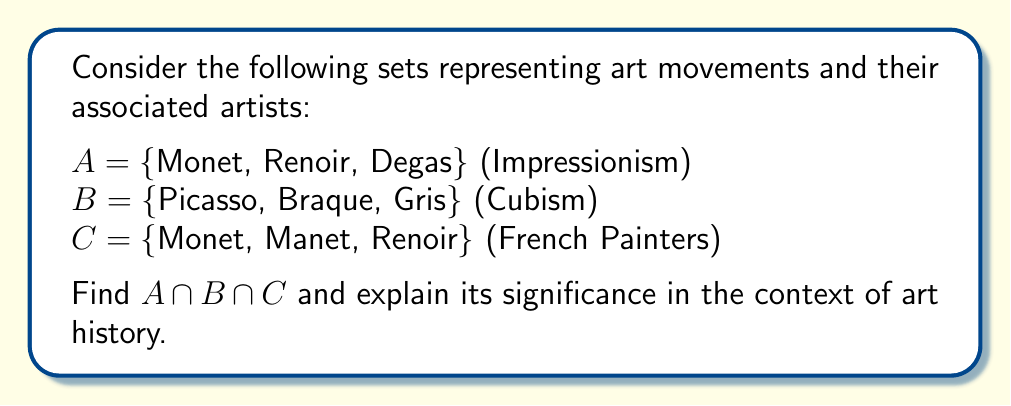Can you answer this question? To solve this problem, we need to find the intersection of all three sets. The intersection of sets contains elements that are common to all the sets involved.

Let's approach this step-by-step:

1) First, let's examine the elements in each set:
   $A = \{$Monet, Renoir, Degas$\}$
   $B = \{$Picasso, Braque, Gris$\}$
   $C = \{$Monet, Manet, Renoir$\}$

2) To find $A \cap B \cap C$, we need to identify elements that appear in all three sets.

3) Comparing $A$ and $B$, we see no common elements:
   $A \cap B = \{\}$

4) Since $A \cap B$ is empty, $A \cap B \cap C$ must also be empty, as there are no elements from $A$ and $B$ that could possibly be in $C$.

5) Therefore, $A \cap B \cap C = \{\}$

In the context of art history, this result is significant because:

a) It shows that there's no artist in this selection who was simultaneously associated with Impressionism, Cubism, and the group of French painters represented here.

b) It highlights the distinct nature of these art movements. Impressionism (represented by set $A$) and Cubism (represented by set $B$) were separate movements with different artists.

c) While some Impressionist artists were French (as seen in the overlap between $A$ and $C$), the Cubists in this selection (set $B$) were not part of the French painters group represented in set $C$.

This demonstrates how set theory can be used to analyze and visualize relationships between different art movements and groups of artists, providing a mathematical perspective on art historical categorizations.
Answer: $A \cap B \cap C = \{\}$ (the empty set) 